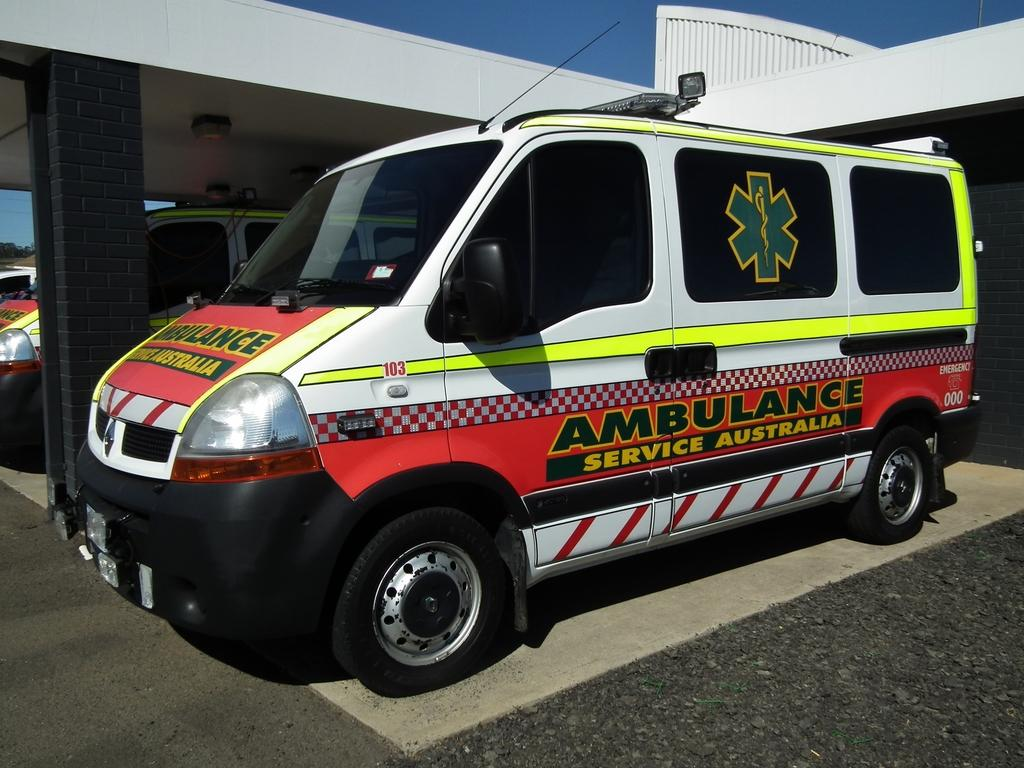<image>
Summarize the visual content of the image. An Ambulance that says Ambulance Service Australia down the side of it. 